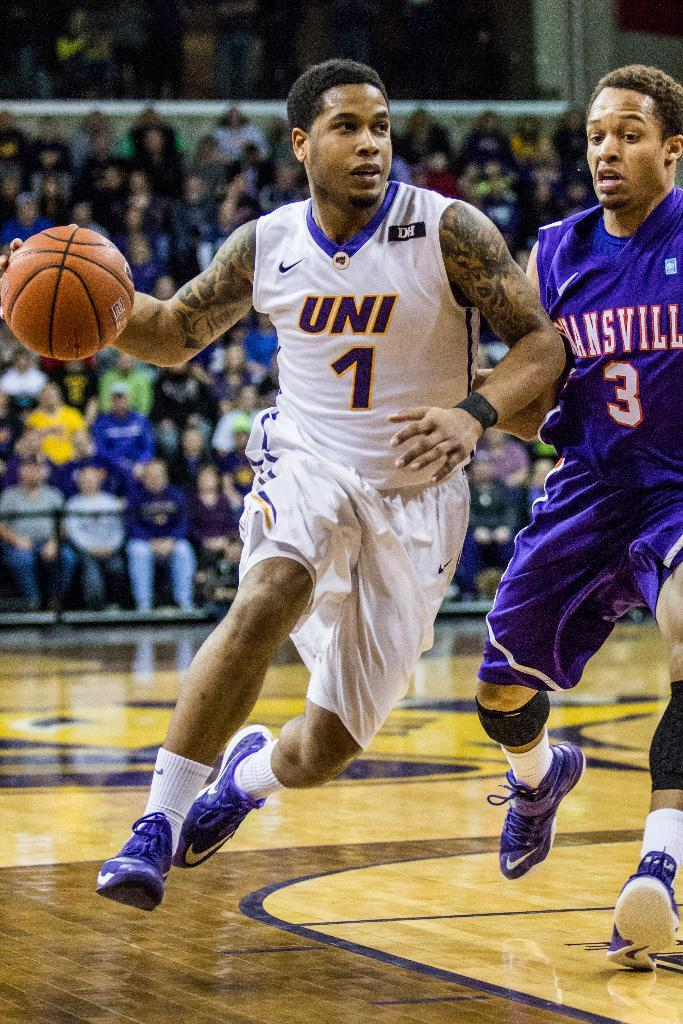What are the two people in the image doing? The two people in the image are playing a game. What can be seen at the bottom of the image? There is a floor visible at the bottom of the image. Can you describe the people in the background of the image? There are people sitting on chairs in the background of the image. What type of oven is being used to treat the injury in the image? There is no oven or injury present in the image; it features two people playing a game and people sitting on chairs in the background. 